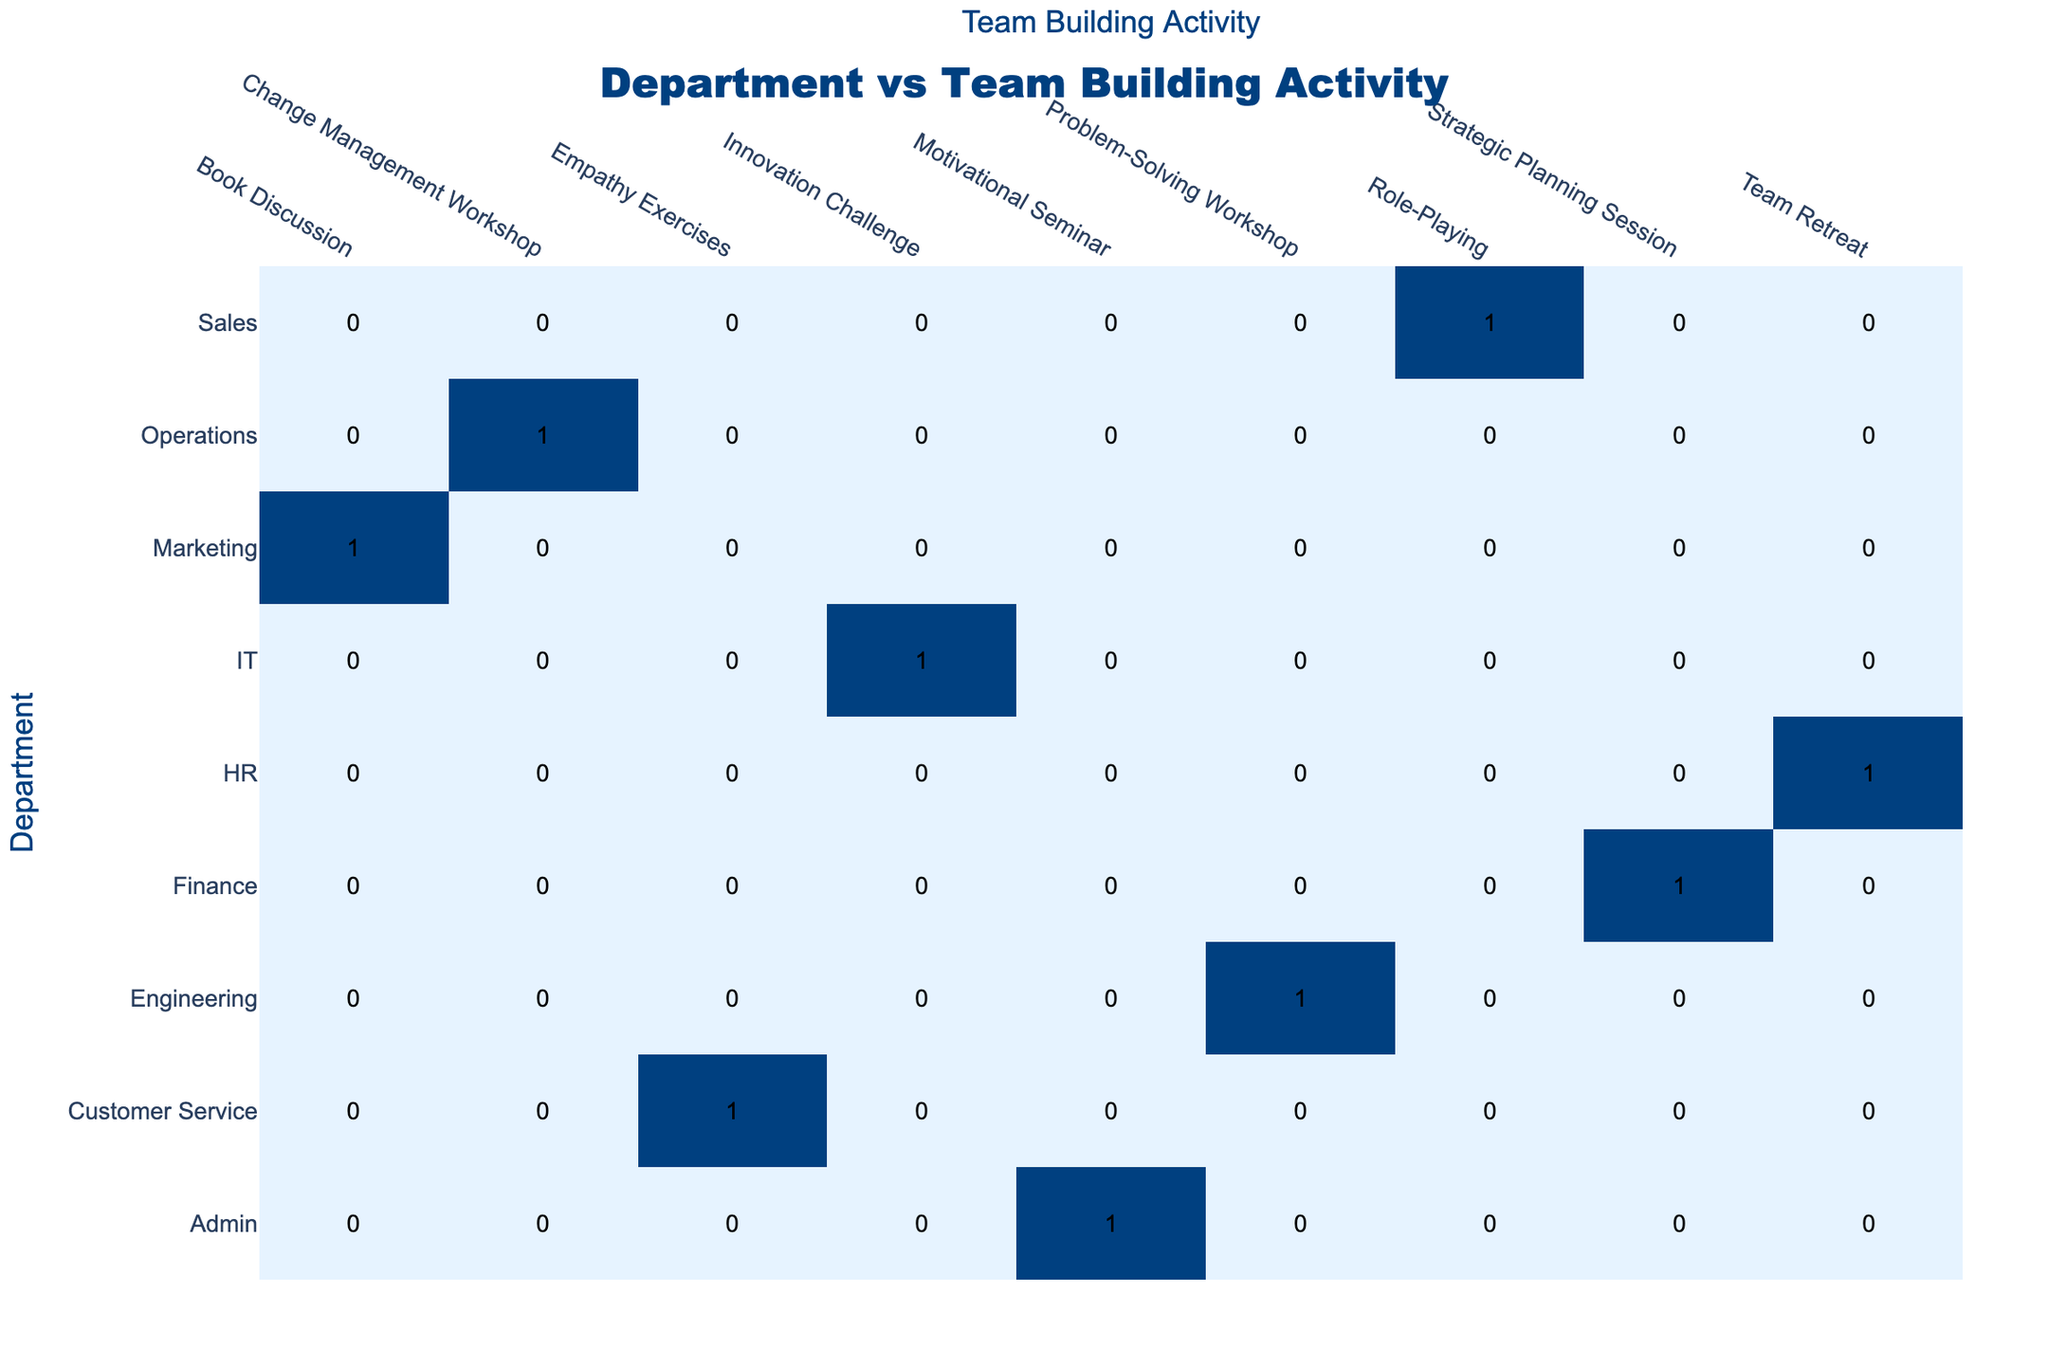What is the total number of team-building activities conducted by the Marketing department? The table indicates the team's participation by department in various activities. Checking the 'Marketing' department row, there is one team-building activity listed: 'Book Discussion.' Thus, the total is 1.
Answer: 1 Which team-building activity had the highest number of participants from different departments? Looking at the table, we see that 'Role-Playing' occurred in the Sales department, while 'Innovation Challenge' and 'Book Discussion' each had activity from one department only. To find the highest participation, only the 'Problem-Solving Workshop' has participants from Engineering and contributed positively. In total, 'Role-Playing' has only one department, which is Sales, making it the highest with other teams having one. Therefore, 'Role-Playing' ties with 'Problem-Solving Workshop' for uniqueness.
Answer: Role-Playing Is the Collaboration Score higher for the 'Change Management Workshop' than for the 'Empathy Exercises'? From the table, the Collaboration Score for 'Change Management Workshop' is 6, whereas for 'Empathy Exercises,' it is 7. Since 6 is not greater than 7, the statement is false.
Answer: No Which department has the number of collaboration scores indicating above-average performance based on the activities they chose? The average collaboration score can be calculated by taking the scores: (8 + 7 + 9 + 8 + 7 + 10 + 6 + 7 + 8) / 9 = 7.78. Looking for scores above this average, the departments with above-average scores include IT (10), Engineering (9), HR (8), and Marketing (8).
Answer: IT, Engineering, HR, Marketing What is the difference in the number of activities between the Finance department and the Operations department? Both the Finance and Operations departments have one listed activity each: 'Strategic Planning Session' and 'Change Management Workshop,’ respectively. Therefore, the difference in activities is 1 - 1 = 0, meaning they have the same number of activities.
Answer: 0 